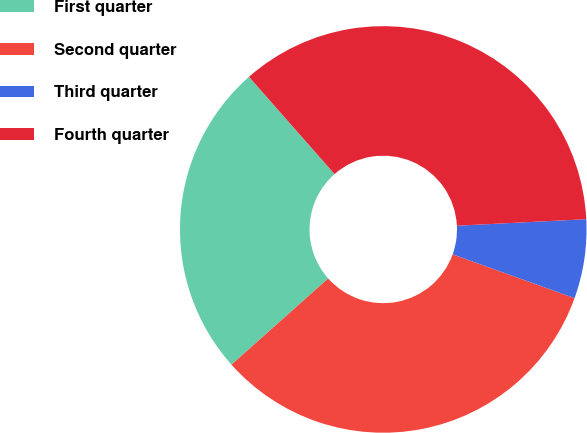Convert chart. <chart><loc_0><loc_0><loc_500><loc_500><pie_chart><fcel>First quarter<fcel>Second quarter<fcel>Third quarter<fcel>Fourth quarter<nl><fcel>25.1%<fcel>32.93%<fcel>6.29%<fcel>35.68%<nl></chart> 